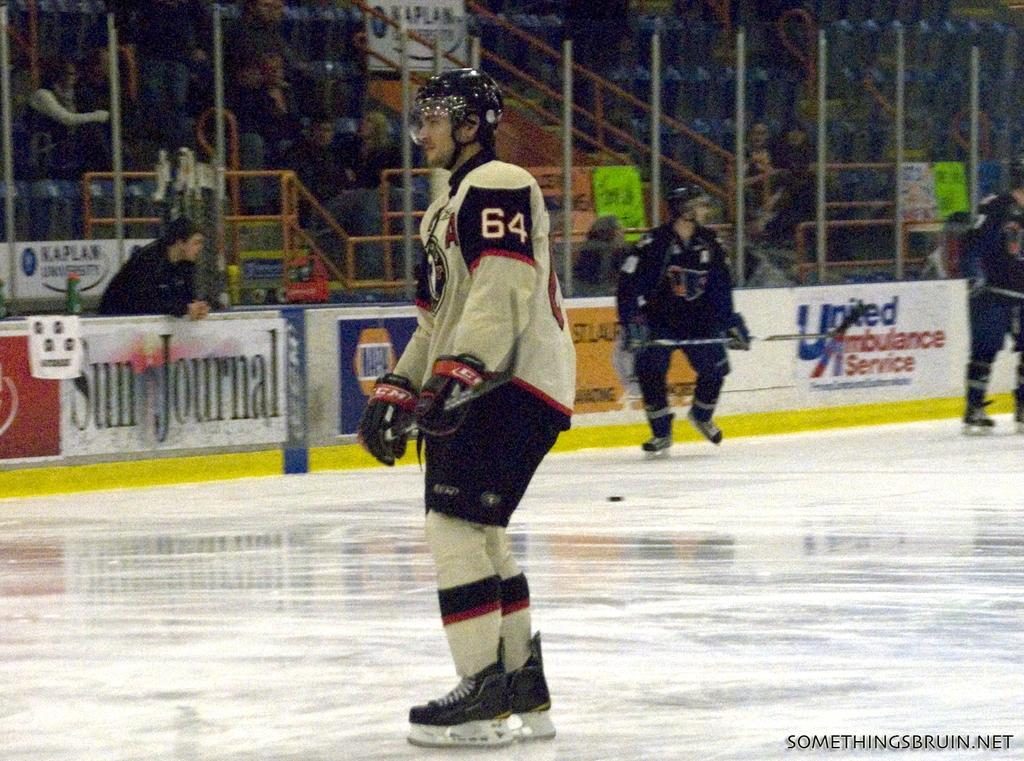<image>
Present a compact description of the photo's key features. A hockey player is standing on the ice wit hhis jersey having the number 64 on his arm. 